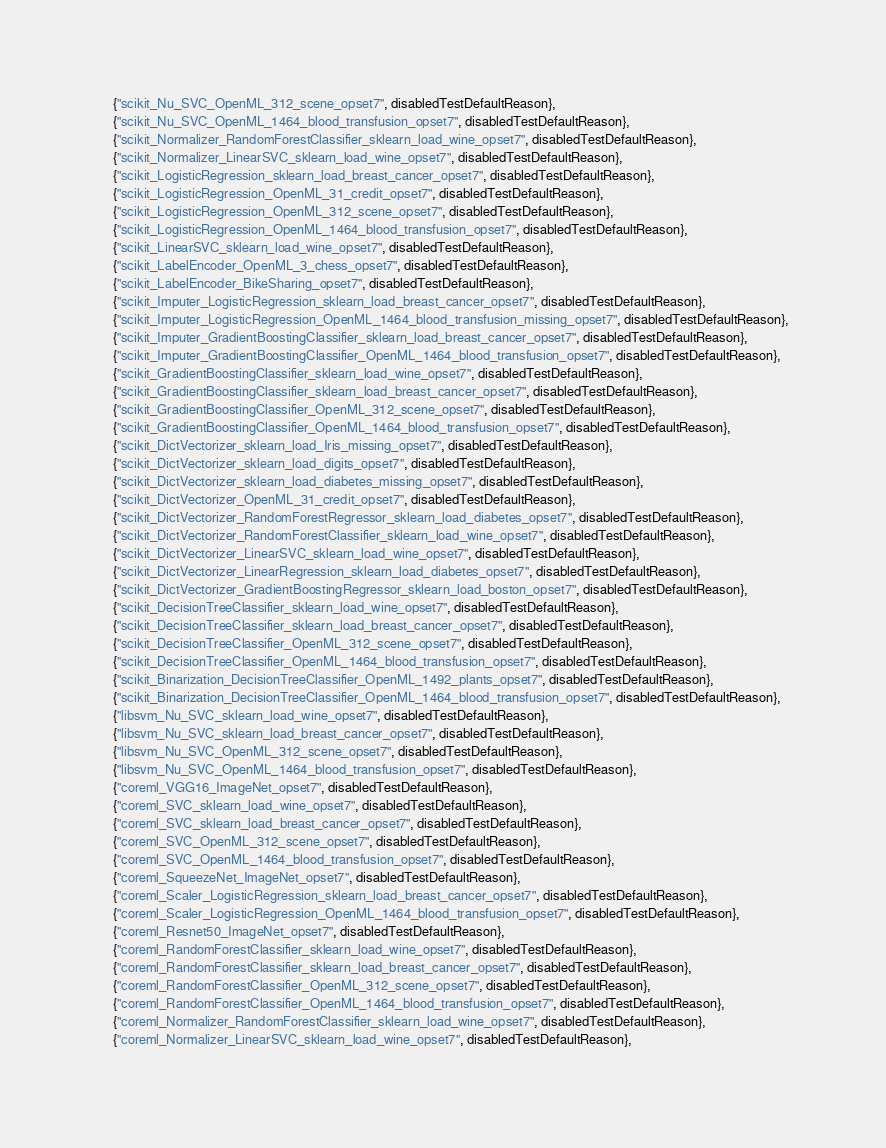Convert code to text. <code><loc_0><loc_0><loc_500><loc_500><_C_>     {"scikit_Nu_SVC_OpenML_312_scene_opset7", disabledTestDefaultReason},
     {"scikit_Nu_SVC_OpenML_1464_blood_transfusion_opset7", disabledTestDefaultReason},
     {"scikit_Normalizer_RandomForestClassifier_sklearn_load_wine_opset7", disabledTestDefaultReason},
     {"scikit_Normalizer_LinearSVC_sklearn_load_wine_opset7", disabledTestDefaultReason},
     {"scikit_LogisticRegression_sklearn_load_breast_cancer_opset7", disabledTestDefaultReason},
     {"scikit_LogisticRegression_OpenML_31_credit_opset7", disabledTestDefaultReason},
     {"scikit_LogisticRegression_OpenML_312_scene_opset7", disabledTestDefaultReason},
     {"scikit_LogisticRegression_OpenML_1464_blood_transfusion_opset7", disabledTestDefaultReason},
     {"scikit_LinearSVC_sklearn_load_wine_opset7", disabledTestDefaultReason},
     {"scikit_LabelEncoder_OpenML_3_chess_opset7", disabledTestDefaultReason},
     {"scikit_LabelEncoder_BikeSharing_opset7", disabledTestDefaultReason},
     {"scikit_Imputer_LogisticRegression_sklearn_load_breast_cancer_opset7", disabledTestDefaultReason},
     {"scikit_Imputer_LogisticRegression_OpenML_1464_blood_transfusion_missing_opset7", disabledTestDefaultReason},
     {"scikit_Imputer_GradientBoostingClassifier_sklearn_load_breast_cancer_opset7", disabledTestDefaultReason},
     {"scikit_Imputer_GradientBoostingClassifier_OpenML_1464_blood_transfusion_opset7", disabledTestDefaultReason},
     {"scikit_GradientBoostingClassifier_sklearn_load_wine_opset7", disabledTestDefaultReason},
     {"scikit_GradientBoostingClassifier_sklearn_load_breast_cancer_opset7", disabledTestDefaultReason},
     {"scikit_GradientBoostingClassifier_OpenML_312_scene_opset7", disabledTestDefaultReason},
     {"scikit_GradientBoostingClassifier_OpenML_1464_blood_transfusion_opset7", disabledTestDefaultReason},
     {"scikit_DictVectorizer_sklearn_load_Iris_missing_opset7", disabledTestDefaultReason},
     {"scikit_DictVectorizer_sklearn_load_digits_opset7", disabledTestDefaultReason},
     {"scikit_DictVectorizer_sklearn_load_diabetes_missing_opset7", disabledTestDefaultReason},
     {"scikit_DictVectorizer_OpenML_31_credit_opset7", disabledTestDefaultReason},
     {"scikit_DictVectorizer_RandomForestRegressor_sklearn_load_diabetes_opset7", disabledTestDefaultReason},
     {"scikit_DictVectorizer_RandomForestClassifier_sklearn_load_wine_opset7", disabledTestDefaultReason},
     {"scikit_DictVectorizer_LinearSVC_sklearn_load_wine_opset7", disabledTestDefaultReason},
     {"scikit_DictVectorizer_LinearRegression_sklearn_load_diabetes_opset7", disabledTestDefaultReason},
     {"scikit_DictVectorizer_GradientBoostingRegressor_sklearn_load_boston_opset7", disabledTestDefaultReason},
     {"scikit_DecisionTreeClassifier_sklearn_load_wine_opset7", disabledTestDefaultReason},
     {"scikit_DecisionTreeClassifier_sklearn_load_breast_cancer_opset7", disabledTestDefaultReason},
     {"scikit_DecisionTreeClassifier_OpenML_312_scene_opset7", disabledTestDefaultReason},
     {"scikit_DecisionTreeClassifier_OpenML_1464_blood_transfusion_opset7", disabledTestDefaultReason},
     {"scikit_Binarization_DecisionTreeClassifier_OpenML_1492_plants_opset7", disabledTestDefaultReason},
     {"scikit_Binarization_DecisionTreeClassifier_OpenML_1464_blood_transfusion_opset7", disabledTestDefaultReason},
     {"libsvm_Nu_SVC_sklearn_load_wine_opset7", disabledTestDefaultReason},
     {"libsvm_Nu_SVC_sklearn_load_breast_cancer_opset7", disabledTestDefaultReason},
     {"libsvm_Nu_SVC_OpenML_312_scene_opset7", disabledTestDefaultReason},
     {"libsvm_Nu_SVC_OpenML_1464_blood_transfusion_opset7", disabledTestDefaultReason},
     {"coreml_VGG16_ImageNet_opset7", disabledTestDefaultReason},
     {"coreml_SVC_sklearn_load_wine_opset7", disabledTestDefaultReason},
     {"coreml_SVC_sklearn_load_breast_cancer_opset7", disabledTestDefaultReason},
     {"coreml_SVC_OpenML_312_scene_opset7", disabledTestDefaultReason},
     {"coreml_SVC_OpenML_1464_blood_transfusion_opset7", disabledTestDefaultReason},
     {"coreml_SqueezeNet_ImageNet_opset7", disabledTestDefaultReason},
     {"coreml_Scaler_LogisticRegression_sklearn_load_breast_cancer_opset7", disabledTestDefaultReason},
     {"coreml_Scaler_LogisticRegression_OpenML_1464_blood_transfusion_opset7", disabledTestDefaultReason},
     {"coreml_Resnet50_ImageNet_opset7", disabledTestDefaultReason},
     {"coreml_RandomForestClassifier_sklearn_load_wine_opset7", disabledTestDefaultReason},
     {"coreml_RandomForestClassifier_sklearn_load_breast_cancer_opset7", disabledTestDefaultReason},
     {"coreml_RandomForestClassifier_OpenML_312_scene_opset7", disabledTestDefaultReason},
     {"coreml_RandomForestClassifier_OpenML_1464_blood_transfusion_opset7", disabledTestDefaultReason},
     {"coreml_Normalizer_RandomForestClassifier_sklearn_load_wine_opset7", disabledTestDefaultReason},
     {"coreml_Normalizer_LinearSVC_sklearn_load_wine_opset7", disabledTestDefaultReason},</code> 